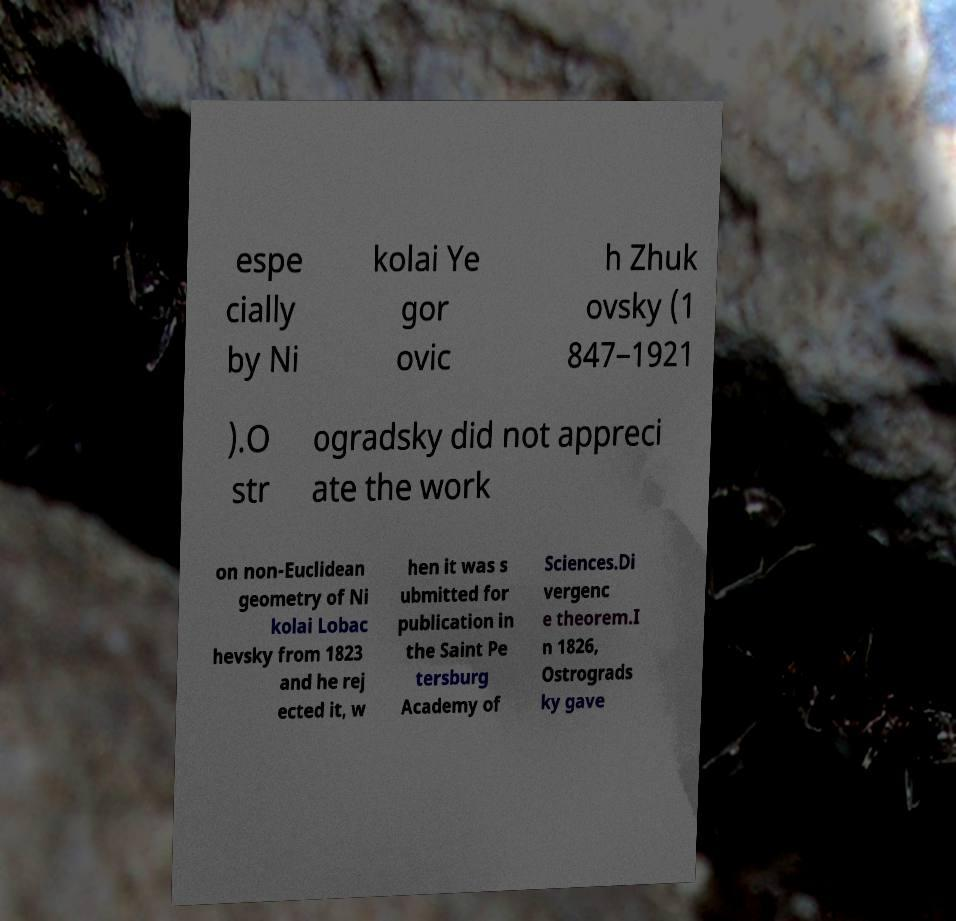Please identify and transcribe the text found in this image. espe cially by Ni kolai Ye gor ovic h Zhuk ovsky (1 847–1921 ).O str ogradsky did not appreci ate the work on non-Euclidean geometry of Ni kolai Lobac hevsky from 1823 and he rej ected it, w hen it was s ubmitted for publication in the Saint Pe tersburg Academy of Sciences.Di vergenc e theorem.I n 1826, Ostrograds ky gave 